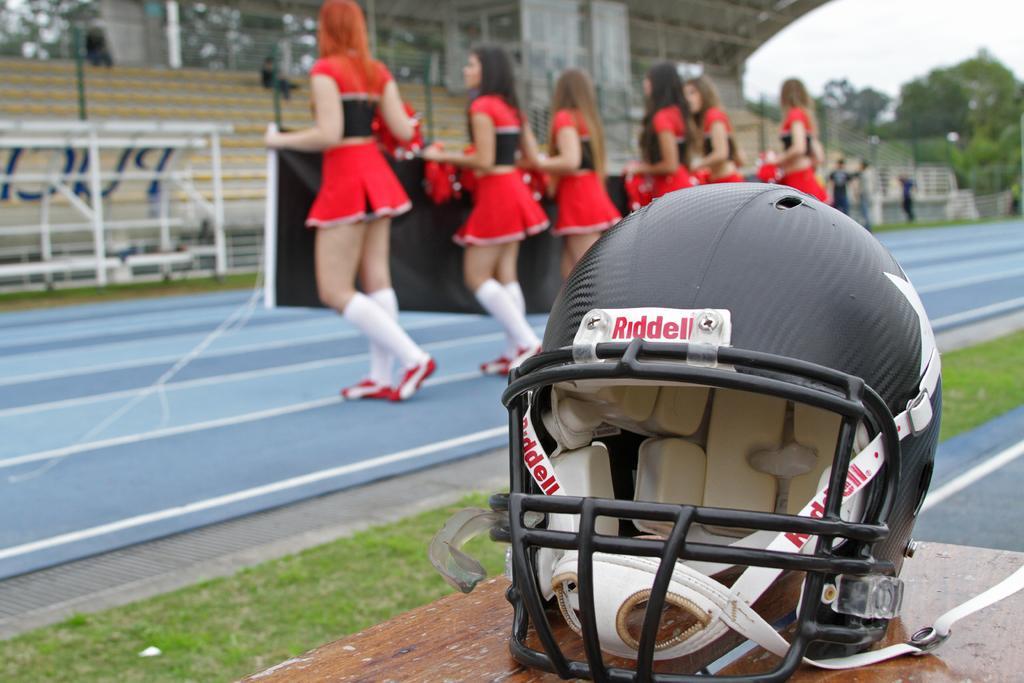In one or two sentences, can you explain what this image depicts? In this picture I can observe black color helmet placed on the brown color table on the right side. In the middle of the picture I can observe six women wearing red color dresses. In the background I can observe trees and sky. 